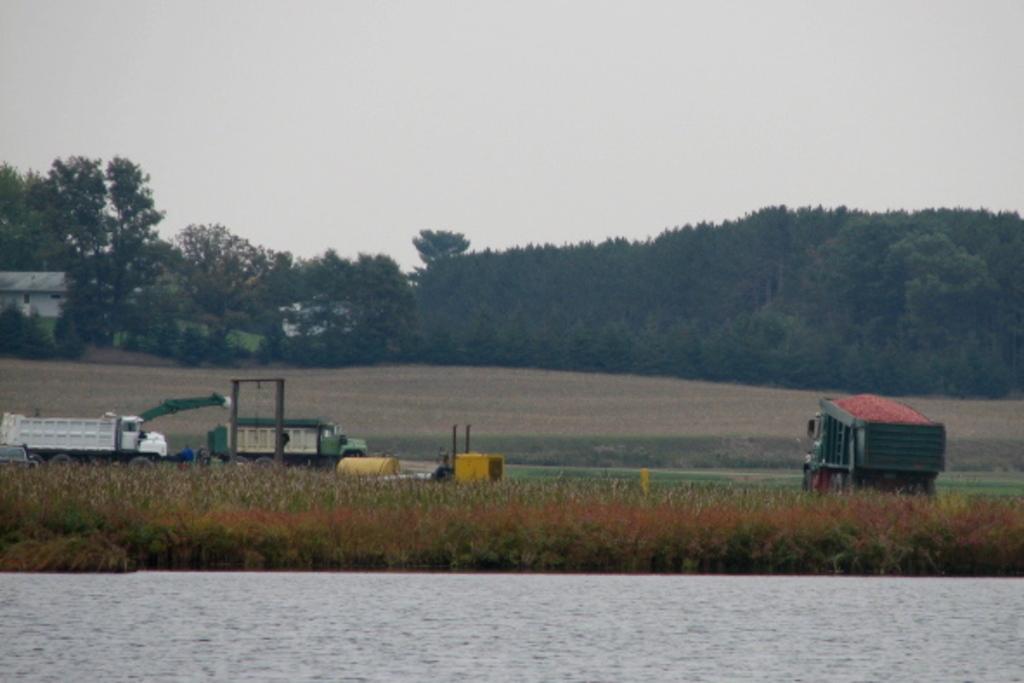Can you describe this image briefly? In this image I can see the water. I can see the grass. I can also see the vehicles. In the background, I can see the trees and the sky. 